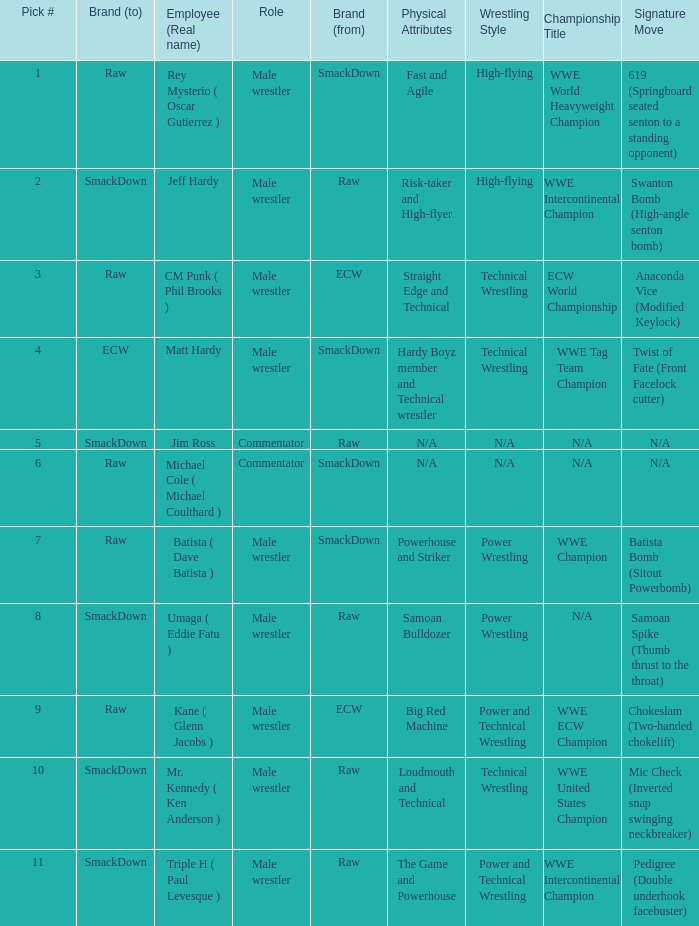What is the real name of the male wrestler from Raw with a pick # smaller than 6? Jeff Hardy. 